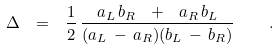Convert formula to latex. <formula><loc_0><loc_0><loc_500><loc_500>\Delta \ = \ \frac { 1 } { 2 } \, \frac { a _ { L } \, b _ { R } \ + \ a _ { R } \, b _ { L } } { ( a _ { L } \, - \, a _ { R } ) ( b _ { L } \, - \, b _ { R } ) } \quad .</formula> 